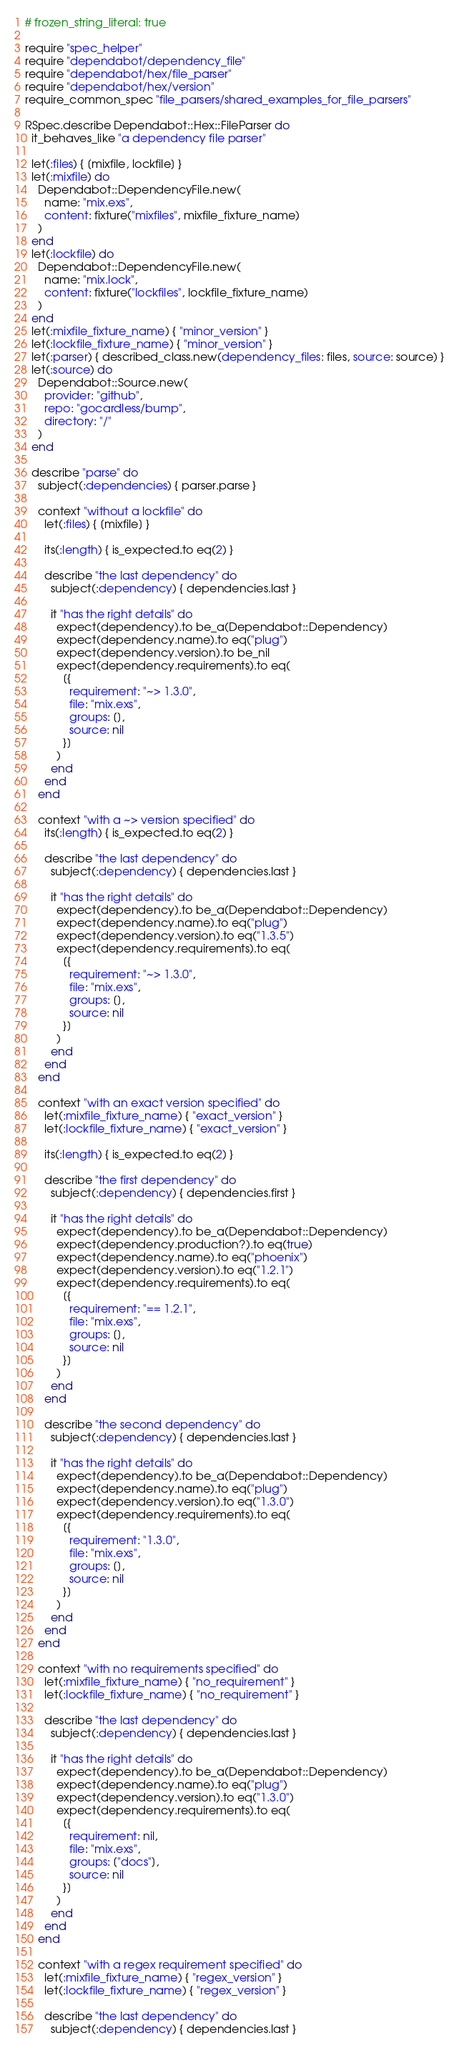Convert code to text. <code><loc_0><loc_0><loc_500><loc_500><_Ruby_># frozen_string_literal: true

require "spec_helper"
require "dependabot/dependency_file"
require "dependabot/hex/file_parser"
require "dependabot/hex/version"
require_common_spec "file_parsers/shared_examples_for_file_parsers"

RSpec.describe Dependabot::Hex::FileParser do
  it_behaves_like "a dependency file parser"

  let(:files) { [mixfile, lockfile] }
  let(:mixfile) do
    Dependabot::DependencyFile.new(
      name: "mix.exs",
      content: fixture("mixfiles", mixfile_fixture_name)
    )
  end
  let(:lockfile) do
    Dependabot::DependencyFile.new(
      name: "mix.lock",
      content: fixture("lockfiles", lockfile_fixture_name)
    )
  end
  let(:mixfile_fixture_name) { "minor_version" }
  let(:lockfile_fixture_name) { "minor_version" }
  let(:parser) { described_class.new(dependency_files: files, source: source) }
  let(:source) do
    Dependabot::Source.new(
      provider: "github",
      repo: "gocardless/bump",
      directory: "/"
    )
  end

  describe "parse" do
    subject(:dependencies) { parser.parse }

    context "without a lockfile" do
      let(:files) { [mixfile] }

      its(:length) { is_expected.to eq(2) }

      describe "the last dependency" do
        subject(:dependency) { dependencies.last }

        it "has the right details" do
          expect(dependency).to be_a(Dependabot::Dependency)
          expect(dependency.name).to eq("plug")
          expect(dependency.version).to be_nil
          expect(dependency.requirements).to eq(
            [{
              requirement: "~> 1.3.0",
              file: "mix.exs",
              groups: [],
              source: nil
            }]
          )
        end
      end
    end

    context "with a ~> version specified" do
      its(:length) { is_expected.to eq(2) }

      describe "the last dependency" do
        subject(:dependency) { dependencies.last }

        it "has the right details" do
          expect(dependency).to be_a(Dependabot::Dependency)
          expect(dependency.name).to eq("plug")
          expect(dependency.version).to eq("1.3.5")
          expect(dependency.requirements).to eq(
            [{
              requirement: "~> 1.3.0",
              file: "mix.exs",
              groups: [],
              source: nil
            }]
          )
        end
      end
    end

    context "with an exact version specified" do
      let(:mixfile_fixture_name) { "exact_version" }
      let(:lockfile_fixture_name) { "exact_version" }

      its(:length) { is_expected.to eq(2) }

      describe "the first dependency" do
        subject(:dependency) { dependencies.first }

        it "has the right details" do
          expect(dependency).to be_a(Dependabot::Dependency)
          expect(dependency.production?).to eq(true)
          expect(dependency.name).to eq("phoenix")
          expect(dependency.version).to eq("1.2.1")
          expect(dependency.requirements).to eq(
            [{
              requirement: "== 1.2.1",
              file: "mix.exs",
              groups: [],
              source: nil
            }]
          )
        end
      end

      describe "the second dependency" do
        subject(:dependency) { dependencies.last }

        it "has the right details" do
          expect(dependency).to be_a(Dependabot::Dependency)
          expect(dependency.name).to eq("plug")
          expect(dependency.version).to eq("1.3.0")
          expect(dependency.requirements).to eq(
            [{
              requirement: "1.3.0",
              file: "mix.exs",
              groups: [],
              source: nil
            }]
          )
        end
      end
    end

    context "with no requirements specified" do
      let(:mixfile_fixture_name) { "no_requirement" }
      let(:lockfile_fixture_name) { "no_requirement" }

      describe "the last dependency" do
        subject(:dependency) { dependencies.last }

        it "has the right details" do
          expect(dependency).to be_a(Dependabot::Dependency)
          expect(dependency.name).to eq("plug")
          expect(dependency.version).to eq("1.3.0")
          expect(dependency.requirements).to eq(
            [{
              requirement: nil,
              file: "mix.exs",
              groups: ["docs"],
              source: nil
            }]
          )
        end
      end
    end

    context "with a regex requirement specified" do
      let(:mixfile_fixture_name) { "regex_version" }
      let(:lockfile_fixture_name) { "regex_version" }

      describe "the last dependency" do
        subject(:dependency) { dependencies.last }
</code> 